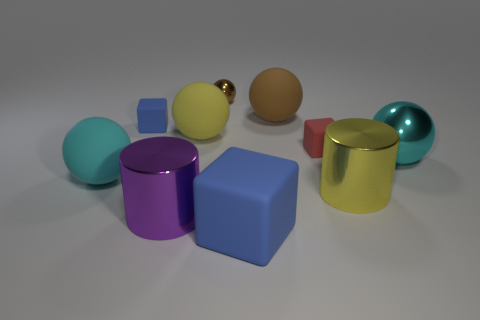Subtract all yellow balls. How many balls are left? 4 Subtract all yellow matte balls. How many balls are left? 4 Subtract all red balls. Subtract all red cylinders. How many balls are left? 5 Subtract all cylinders. How many objects are left? 8 Subtract 0 yellow blocks. How many objects are left? 10 Subtract all big green rubber balls. Subtract all rubber things. How many objects are left? 4 Add 4 large yellow objects. How many large yellow objects are left? 6 Add 2 brown spheres. How many brown spheres exist? 4 